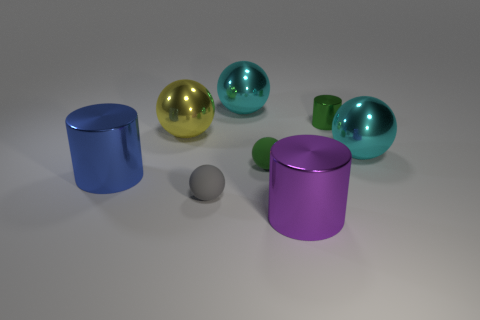Subtract all yellow balls. How many balls are left? 4 Subtract all green spheres. How many spheres are left? 4 Add 2 green cylinders. How many objects exist? 10 Subtract all blue balls. Subtract all cyan cylinders. How many balls are left? 5 Subtract all balls. How many objects are left? 3 Subtract all tiny purple metallic balls. Subtract all purple shiny things. How many objects are left? 7 Add 1 green objects. How many green objects are left? 3 Add 5 big purple shiny things. How many big purple shiny things exist? 6 Subtract 2 cyan spheres. How many objects are left? 6 